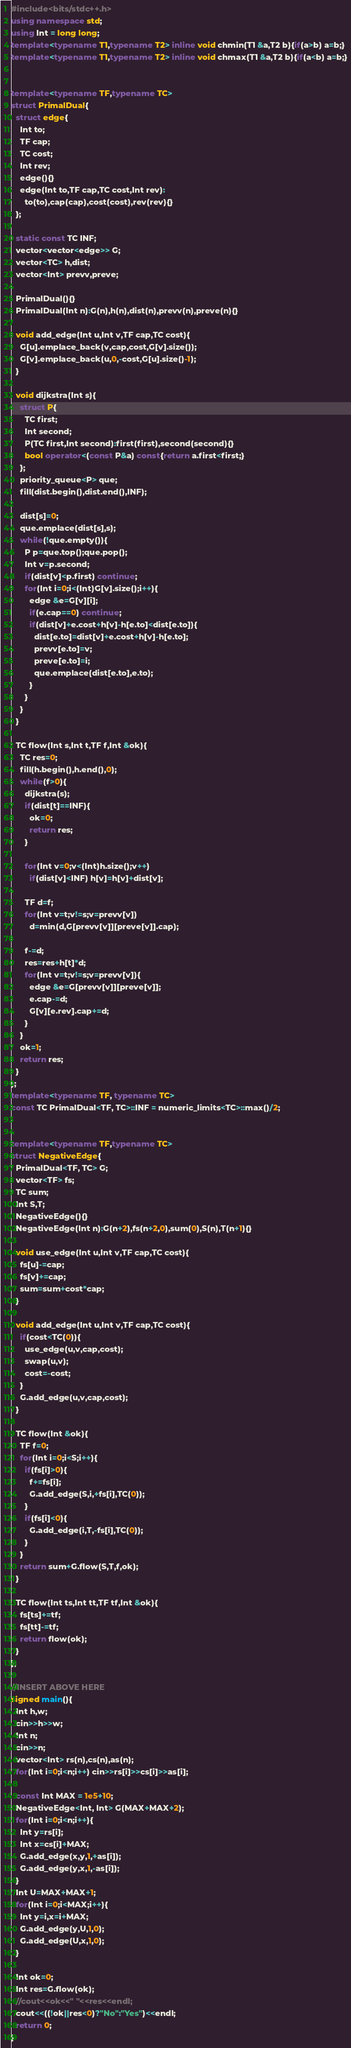Convert code to text. <code><loc_0><loc_0><loc_500><loc_500><_C++_>#include<bits/stdc++.h>
using namespace std;
using Int = long long;
template<typename T1,typename T2> inline void chmin(T1 &a,T2 b){if(a>b) a=b;}
template<typename T1,typename T2> inline void chmax(T1 &a,T2 b){if(a<b) a=b;}


template<typename TF,typename TC>
struct PrimalDual{
  struct edge{
    Int to;
    TF cap;
    TC cost;
    Int rev;
    edge(){}
    edge(Int to,TF cap,TC cost,Int rev):
      to(to),cap(cap),cost(cost),rev(rev){}
  };

  static const TC INF;
  vector<vector<edge>> G;
  vector<TC> h,dist;
  vector<Int> prevv,preve;

  PrimalDual(){}
  PrimalDual(Int n):G(n),h(n),dist(n),prevv(n),preve(n){}

  void add_edge(Int u,Int v,TF cap,TC cost){
    G[u].emplace_back(v,cap,cost,G[v].size());
    G[v].emplace_back(u,0,-cost,G[u].size()-1);
  }

  void dijkstra(Int s){
    struct P{
      TC first;
      Int second;
      P(TC first,Int second):first(first),second(second){}
      bool operator<(const P&a) const{return a.first<first;}
    };
    priority_queue<P> que;
    fill(dist.begin(),dist.end(),INF);

    dist[s]=0;
    que.emplace(dist[s],s);
    while(!que.empty()){
      P p=que.top();que.pop();
      Int v=p.second;
      if(dist[v]<p.first) continue;
      for(Int i=0;i<(Int)G[v].size();i++){
        edge &e=G[v][i];
        if(e.cap==0) continue;
        if(dist[v]+e.cost+h[v]-h[e.to]<dist[e.to]){
          dist[e.to]=dist[v]+e.cost+h[v]-h[e.to];
          prevv[e.to]=v;
          preve[e.to]=i;
          que.emplace(dist[e.to],e.to);
        }
      }
    }
  }

  TC flow(Int s,Int t,TF f,Int &ok){
    TC res=0;
    fill(h.begin(),h.end(),0);
    while(f>0){
      dijkstra(s);
      if(dist[t]==INF){
        ok=0;
        return res;
      }

      for(Int v=0;v<(Int)h.size();v++)
        if(dist[v]<INF) h[v]=h[v]+dist[v];

      TF d=f;
      for(Int v=t;v!=s;v=prevv[v])
        d=min(d,G[prevv[v]][preve[v]].cap);

      f-=d;
      res=res+h[t]*d;
      for(Int v=t;v!=s;v=prevv[v]){
        edge &e=G[prevv[v]][preve[v]];
        e.cap-=d;
        G[v][e.rev].cap+=d;
      }
    }
    ok=1;
    return res;
  }
};
template<typename TF, typename TC>
const TC PrimalDual<TF, TC>::INF = numeric_limits<TC>::max()/2;


template<typename TF,typename TC>
struct NegativeEdge{
  PrimalDual<TF, TC> G;
  vector<TF> fs;
  TC sum;
  Int S,T;
  NegativeEdge(){}
  NegativeEdge(Int n):G(n+2),fs(n+2,0),sum(0),S(n),T(n+1){}

  void use_edge(Int u,Int v,TF cap,TC cost){
    fs[u]-=cap;
    fs[v]+=cap;
    sum=sum+cost*cap;
  }

  void add_edge(Int u,Int v,TF cap,TC cost){
    if(cost<TC(0)){
      use_edge(u,v,cap,cost);
      swap(u,v);
      cost=-cost;
    }
    G.add_edge(u,v,cap,cost);
  }

  TC flow(Int &ok){
    TF f=0;
    for(Int i=0;i<S;i++){
      if(fs[i]>0){
        f+=fs[i];
        G.add_edge(S,i,+fs[i],TC(0));
      }
      if(fs[i]<0){
        G.add_edge(i,T,-fs[i],TC(0));
      }
    }
    return sum+G.flow(S,T,f,ok);
  }

  TC flow(Int ts,Int tt,TF tf,Int &ok){
    fs[ts]+=tf;
    fs[tt]-=tf;
    return flow(ok);
  }
};

//INSERT ABOVE HERE
signed main(){
  Int h,w;
  cin>>h>>w;
  Int n;
  cin>>n;
  vector<Int> rs(n),cs(n),as(n);
  for(Int i=0;i<n;i++) cin>>rs[i]>>cs[i]>>as[i];

  const Int MAX = 1e5+10;
  NegativeEdge<Int, Int> G(MAX+MAX+2);
  for(Int i=0;i<n;i++){
    Int y=rs[i];
    Int x=cs[i]+MAX;
    G.add_edge(x,y,1,+as[i]);
    G.add_edge(y,x,1,-as[i]);
  }
  Int U=MAX+MAX+1;
  for(Int i=0;i<MAX;i++){
    Int y=i,x=i+MAX;
    G.add_edge(y,U,1,0);
    G.add_edge(U,x,1,0);
  }

  Int ok=0;
  Int res=G.flow(ok);
  //cout<<ok<<" "<<res<<endl;
  cout<<((!ok||res<0)?"No":"Yes")<<endl;
  return 0;
}
</code> 